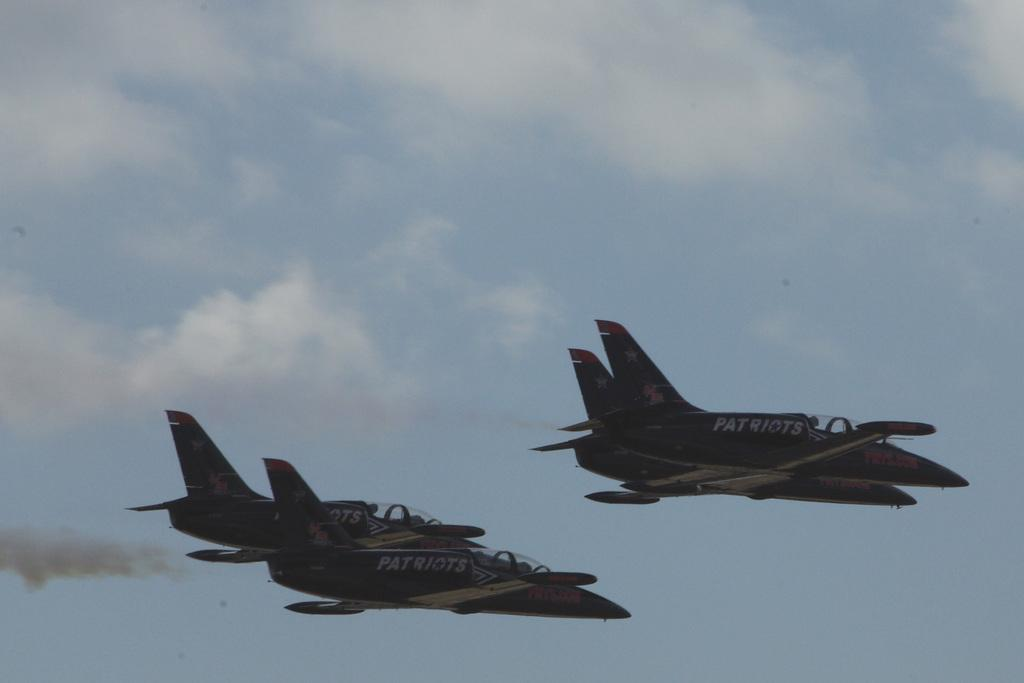What type of vehicles are in the picture? There are jet planes in the picture. How would you describe the sky in the image? The sky is blue and cloudy. What type of apparel is being requested by the jet planes in the image? There are no people or apparel mentioned in the image, as it features jet planes and a blue, cloudy sky. 